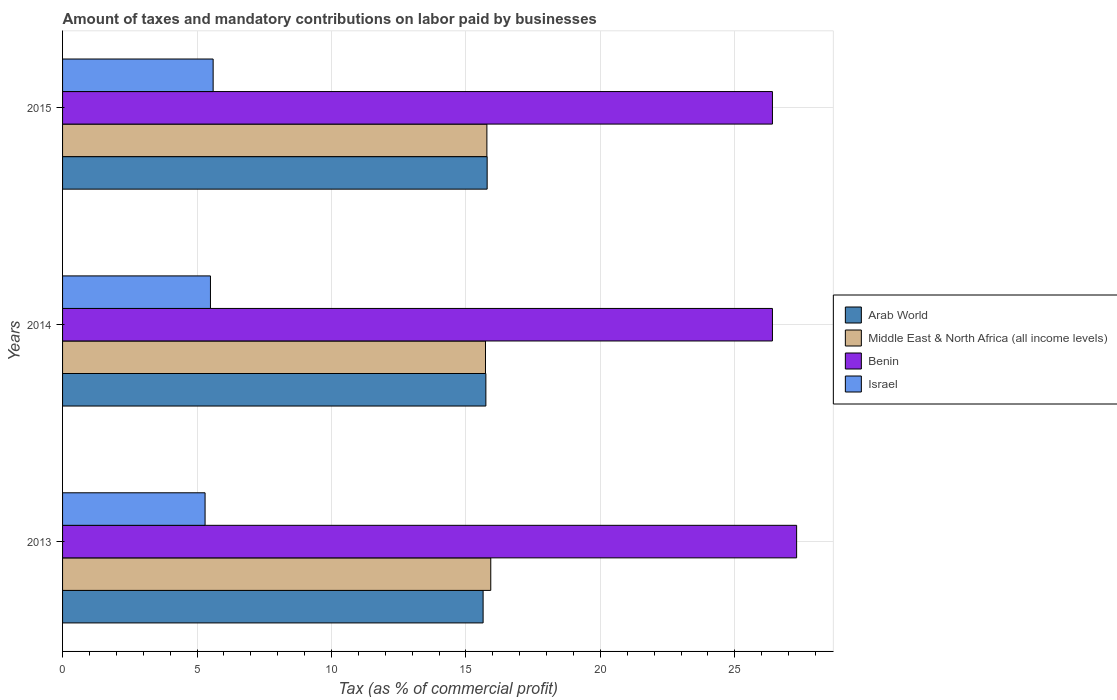How many bars are there on the 2nd tick from the bottom?
Offer a very short reply. 4. What is the label of the 3rd group of bars from the top?
Your response must be concise. 2013. In how many cases, is the number of bars for a given year not equal to the number of legend labels?
Your response must be concise. 0. What is the percentage of taxes paid by businesses in Benin in 2015?
Give a very brief answer. 26.4. Across all years, what is the maximum percentage of taxes paid by businesses in Israel?
Your answer should be very brief. 5.6. Across all years, what is the minimum percentage of taxes paid by businesses in Arab World?
Provide a short and direct response. 15.64. In which year was the percentage of taxes paid by businesses in Israel maximum?
Your response must be concise. 2015. What is the total percentage of taxes paid by businesses in Middle East & North Africa (all income levels) in the graph?
Keep it short and to the point. 47.43. What is the difference between the percentage of taxes paid by businesses in Arab World in 2013 and that in 2015?
Your response must be concise. -0.15. What is the difference between the percentage of taxes paid by businesses in Benin in 2014 and the percentage of taxes paid by businesses in Arab World in 2015?
Provide a succinct answer. 10.61. What is the average percentage of taxes paid by businesses in Israel per year?
Provide a short and direct response. 5.47. In the year 2015, what is the difference between the percentage of taxes paid by businesses in Israel and percentage of taxes paid by businesses in Middle East & North Africa (all income levels)?
Keep it short and to the point. -10.18. In how many years, is the percentage of taxes paid by businesses in Benin greater than 25 %?
Your response must be concise. 3. What is the ratio of the percentage of taxes paid by businesses in Israel in 2013 to that in 2014?
Offer a terse response. 0.96. Is the difference between the percentage of taxes paid by businesses in Israel in 2014 and 2015 greater than the difference between the percentage of taxes paid by businesses in Middle East & North Africa (all income levels) in 2014 and 2015?
Your response must be concise. No. What is the difference between the highest and the second highest percentage of taxes paid by businesses in Middle East & North Africa (all income levels)?
Ensure brevity in your answer.  0.14. What is the difference between the highest and the lowest percentage of taxes paid by businesses in Middle East & North Africa (all income levels)?
Give a very brief answer. 0.2. Is the sum of the percentage of taxes paid by businesses in Middle East & North Africa (all income levels) in 2013 and 2014 greater than the maximum percentage of taxes paid by businesses in Arab World across all years?
Offer a very short reply. Yes. What does the 3rd bar from the top in 2013 represents?
Offer a terse response. Middle East & North Africa (all income levels). What does the 3rd bar from the bottom in 2014 represents?
Provide a succinct answer. Benin. Is it the case that in every year, the sum of the percentage of taxes paid by businesses in Benin and percentage of taxes paid by businesses in Israel is greater than the percentage of taxes paid by businesses in Arab World?
Make the answer very short. Yes. How many bars are there?
Keep it short and to the point. 12. How many years are there in the graph?
Provide a succinct answer. 3. Are the values on the major ticks of X-axis written in scientific E-notation?
Your answer should be compact. No. Does the graph contain grids?
Your answer should be compact. Yes. How are the legend labels stacked?
Give a very brief answer. Vertical. What is the title of the graph?
Ensure brevity in your answer.  Amount of taxes and mandatory contributions on labor paid by businesses. Does "Swaziland" appear as one of the legend labels in the graph?
Provide a succinct answer. No. What is the label or title of the X-axis?
Provide a short and direct response. Tax (as % of commercial profit). What is the Tax (as % of commercial profit) in Arab World in 2013?
Offer a very short reply. 15.64. What is the Tax (as % of commercial profit) of Middle East & North Africa (all income levels) in 2013?
Make the answer very short. 15.93. What is the Tax (as % of commercial profit) of Benin in 2013?
Keep it short and to the point. 27.3. What is the Tax (as % of commercial profit) in Arab World in 2014?
Offer a terse response. 15.74. What is the Tax (as % of commercial profit) of Middle East & North Africa (all income levels) in 2014?
Offer a very short reply. 15.73. What is the Tax (as % of commercial profit) of Benin in 2014?
Ensure brevity in your answer.  26.4. What is the Tax (as % of commercial profit) in Israel in 2014?
Your response must be concise. 5.5. What is the Tax (as % of commercial profit) in Arab World in 2015?
Keep it short and to the point. 15.79. What is the Tax (as % of commercial profit) in Middle East & North Africa (all income levels) in 2015?
Give a very brief answer. 15.78. What is the Tax (as % of commercial profit) in Benin in 2015?
Make the answer very short. 26.4. Across all years, what is the maximum Tax (as % of commercial profit) of Arab World?
Your answer should be compact. 15.79. Across all years, what is the maximum Tax (as % of commercial profit) of Middle East & North Africa (all income levels)?
Offer a terse response. 15.93. Across all years, what is the maximum Tax (as % of commercial profit) in Benin?
Provide a short and direct response. 27.3. Across all years, what is the minimum Tax (as % of commercial profit) of Arab World?
Provide a short and direct response. 15.64. Across all years, what is the minimum Tax (as % of commercial profit) of Middle East & North Africa (all income levels)?
Keep it short and to the point. 15.73. Across all years, what is the minimum Tax (as % of commercial profit) in Benin?
Keep it short and to the point. 26.4. What is the total Tax (as % of commercial profit) of Arab World in the graph?
Make the answer very short. 47.17. What is the total Tax (as % of commercial profit) of Middle East & North Africa (all income levels) in the graph?
Offer a very short reply. 47.43. What is the total Tax (as % of commercial profit) of Benin in the graph?
Provide a short and direct response. 80.1. What is the total Tax (as % of commercial profit) of Israel in the graph?
Your answer should be compact. 16.4. What is the difference between the Tax (as % of commercial profit) in Arab World in 2013 and that in 2014?
Your answer should be compact. -0.1. What is the difference between the Tax (as % of commercial profit) of Middle East & North Africa (all income levels) in 2013 and that in 2014?
Make the answer very short. 0.2. What is the difference between the Tax (as % of commercial profit) in Arab World in 2013 and that in 2015?
Offer a terse response. -0.15. What is the difference between the Tax (as % of commercial profit) in Middle East & North Africa (all income levels) in 2013 and that in 2015?
Make the answer very short. 0.14. What is the difference between the Tax (as % of commercial profit) of Benin in 2013 and that in 2015?
Ensure brevity in your answer.  0.9. What is the difference between the Tax (as % of commercial profit) of Arab World in 2014 and that in 2015?
Give a very brief answer. -0.05. What is the difference between the Tax (as % of commercial profit) of Middle East & North Africa (all income levels) in 2014 and that in 2015?
Your answer should be very brief. -0.05. What is the difference between the Tax (as % of commercial profit) in Benin in 2014 and that in 2015?
Give a very brief answer. 0. What is the difference between the Tax (as % of commercial profit) of Israel in 2014 and that in 2015?
Give a very brief answer. -0.1. What is the difference between the Tax (as % of commercial profit) in Arab World in 2013 and the Tax (as % of commercial profit) in Middle East & North Africa (all income levels) in 2014?
Your answer should be very brief. -0.09. What is the difference between the Tax (as % of commercial profit) in Arab World in 2013 and the Tax (as % of commercial profit) in Benin in 2014?
Keep it short and to the point. -10.76. What is the difference between the Tax (as % of commercial profit) of Arab World in 2013 and the Tax (as % of commercial profit) of Israel in 2014?
Make the answer very short. 10.14. What is the difference between the Tax (as % of commercial profit) of Middle East & North Africa (all income levels) in 2013 and the Tax (as % of commercial profit) of Benin in 2014?
Your response must be concise. -10.47. What is the difference between the Tax (as % of commercial profit) of Middle East & North Africa (all income levels) in 2013 and the Tax (as % of commercial profit) of Israel in 2014?
Keep it short and to the point. 10.43. What is the difference between the Tax (as % of commercial profit) of Benin in 2013 and the Tax (as % of commercial profit) of Israel in 2014?
Your answer should be very brief. 21.8. What is the difference between the Tax (as % of commercial profit) in Arab World in 2013 and the Tax (as % of commercial profit) in Middle East & North Africa (all income levels) in 2015?
Give a very brief answer. -0.14. What is the difference between the Tax (as % of commercial profit) in Arab World in 2013 and the Tax (as % of commercial profit) in Benin in 2015?
Your response must be concise. -10.76. What is the difference between the Tax (as % of commercial profit) of Arab World in 2013 and the Tax (as % of commercial profit) of Israel in 2015?
Keep it short and to the point. 10.04. What is the difference between the Tax (as % of commercial profit) of Middle East & North Africa (all income levels) in 2013 and the Tax (as % of commercial profit) of Benin in 2015?
Provide a short and direct response. -10.47. What is the difference between the Tax (as % of commercial profit) of Middle East & North Africa (all income levels) in 2013 and the Tax (as % of commercial profit) of Israel in 2015?
Give a very brief answer. 10.32. What is the difference between the Tax (as % of commercial profit) in Benin in 2013 and the Tax (as % of commercial profit) in Israel in 2015?
Keep it short and to the point. 21.7. What is the difference between the Tax (as % of commercial profit) of Arab World in 2014 and the Tax (as % of commercial profit) of Middle East & North Africa (all income levels) in 2015?
Your answer should be compact. -0.04. What is the difference between the Tax (as % of commercial profit) in Arab World in 2014 and the Tax (as % of commercial profit) in Benin in 2015?
Keep it short and to the point. -10.66. What is the difference between the Tax (as % of commercial profit) in Arab World in 2014 and the Tax (as % of commercial profit) in Israel in 2015?
Offer a very short reply. 10.14. What is the difference between the Tax (as % of commercial profit) of Middle East & North Africa (all income levels) in 2014 and the Tax (as % of commercial profit) of Benin in 2015?
Offer a very short reply. -10.67. What is the difference between the Tax (as % of commercial profit) of Middle East & North Africa (all income levels) in 2014 and the Tax (as % of commercial profit) of Israel in 2015?
Make the answer very short. 10.13. What is the difference between the Tax (as % of commercial profit) in Benin in 2014 and the Tax (as % of commercial profit) in Israel in 2015?
Your answer should be compact. 20.8. What is the average Tax (as % of commercial profit) in Arab World per year?
Provide a short and direct response. 15.72. What is the average Tax (as % of commercial profit) in Middle East & North Africa (all income levels) per year?
Your answer should be compact. 15.81. What is the average Tax (as % of commercial profit) of Benin per year?
Give a very brief answer. 26.7. What is the average Tax (as % of commercial profit) in Israel per year?
Provide a succinct answer. 5.47. In the year 2013, what is the difference between the Tax (as % of commercial profit) in Arab World and Tax (as % of commercial profit) in Middle East & North Africa (all income levels)?
Keep it short and to the point. -0.28. In the year 2013, what is the difference between the Tax (as % of commercial profit) of Arab World and Tax (as % of commercial profit) of Benin?
Offer a very short reply. -11.66. In the year 2013, what is the difference between the Tax (as % of commercial profit) of Arab World and Tax (as % of commercial profit) of Israel?
Offer a very short reply. 10.34. In the year 2013, what is the difference between the Tax (as % of commercial profit) in Middle East & North Africa (all income levels) and Tax (as % of commercial profit) in Benin?
Offer a very short reply. -11.38. In the year 2013, what is the difference between the Tax (as % of commercial profit) of Middle East & North Africa (all income levels) and Tax (as % of commercial profit) of Israel?
Offer a terse response. 10.62. In the year 2014, what is the difference between the Tax (as % of commercial profit) in Arab World and Tax (as % of commercial profit) in Middle East & North Africa (all income levels)?
Make the answer very short. 0.01. In the year 2014, what is the difference between the Tax (as % of commercial profit) in Arab World and Tax (as % of commercial profit) in Benin?
Provide a short and direct response. -10.66. In the year 2014, what is the difference between the Tax (as % of commercial profit) of Arab World and Tax (as % of commercial profit) of Israel?
Your response must be concise. 10.24. In the year 2014, what is the difference between the Tax (as % of commercial profit) in Middle East & North Africa (all income levels) and Tax (as % of commercial profit) in Benin?
Provide a succinct answer. -10.67. In the year 2014, what is the difference between the Tax (as % of commercial profit) of Middle East & North Africa (all income levels) and Tax (as % of commercial profit) of Israel?
Provide a short and direct response. 10.23. In the year 2014, what is the difference between the Tax (as % of commercial profit) of Benin and Tax (as % of commercial profit) of Israel?
Give a very brief answer. 20.9. In the year 2015, what is the difference between the Tax (as % of commercial profit) of Arab World and Tax (as % of commercial profit) of Middle East & North Africa (all income levels)?
Keep it short and to the point. 0.01. In the year 2015, what is the difference between the Tax (as % of commercial profit) in Arab World and Tax (as % of commercial profit) in Benin?
Provide a short and direct response. -10.61. In the year 2015, what is the difference between the Tax (as % of commercial profit) in Arab World and Tax (as % of commercial profit) in Israel?
Make the answer very short. 10.19. In the year 2015, what is the difference between the Tax (as % of commercial profit) in Middle East & North Africa (all income levels) and Tax (as % of commercial profit) in Benin?
Ensure brevity in your answer.  -10.62. In the year 2015, what is the difference between the Tax (as % of commercial profit) in Middle East & North Africa (all income levels) and Tax (as % of commercial profit) in Israel?
Provide a succinct answer. 10.18. In the year 2015, what is the difference between the Tax (as % of commercial profit) in Benin and Tax (as % of commercial profit) in Israel?
Your answer should be compact. 20.8. What is the ratio of the Tax (as % of commercial profit) of Arab World in 2013 to that in 2014?
Keep it short and to the point. 0.99. What is the ratio of the Tax (as % of commercial profit) of Middle East & North Africa (all income levels) in 2013 to that in 2014?
Give a very brief answer. 1.01. What is the ratio of the Tax (as % of commercial profit) of Benin in 2013 to that in 2014?
Provide a short and direct response. 1.03. What is the ratio of the Tax (as % of commercial profit) of Israel in 2013 to that in 2014?
Your response must be concise. 0.96. What is the ratio of the Tax (as % of commercial profit) in Arab World in 2013 to that in 2015?
Ensure brevity in your answer.  0.99. What is the ratio of the Tax (as % of commercial profit) of Middle East & North Africa (all income levels) in 2013 to that in 2015?
Your answer should be very brief. 1.01. What is the ratio of the Tax (as % of commercial profit) of Benin in 2013 to that in 2015?
Your answer should be very brief. 1.03. What is the ratio of the Tax (as % of commercial profit) in Israel in 2013 to that in 2015?
Offer a terse response. 0.95. What is the ratio of the Tax (as % of commercial profit) of Arab World in 2014 to that in 2015?
Keep it short and to the point. 1. What is the ratio of the Tax (as % of commercial profit) in Benin in 2014 to that in 2015?
Offer a very short reply. 1. What is the ratio of the Tax (as % of commercial profit) in Israel in 2014 to that in 2015?
Your response must be concise. 0.98. What is the difference between the highest and the second highest Tax (as % of commercial profit) of Arab World?
Your response must be concise. 0.05. What is the difference between the highest and the second highest Tax (as % of commercial profit) of Middle East & North Africa (all income levels)?
Ensure brevity in your answer.  0.14. What is the difference between the highest and the second highest Tax (as % of commercial profit) of Israel?
Your response must be concise. 0.1. What is the difference between the highest and the lowest Tax (as % of commercial profit) of Arab World?
Your answer should be compact. 0.15. What is the difference between the highest and the lowest Tax (as % of commercial profit) of Middle East & North Africa (all income levels)?
Your answer should be very brief. 0.2. What is the difference between the highest and the lowest Tax (as % of commercial profit) of Benin?
Provide a short and direct response. 0.9. 